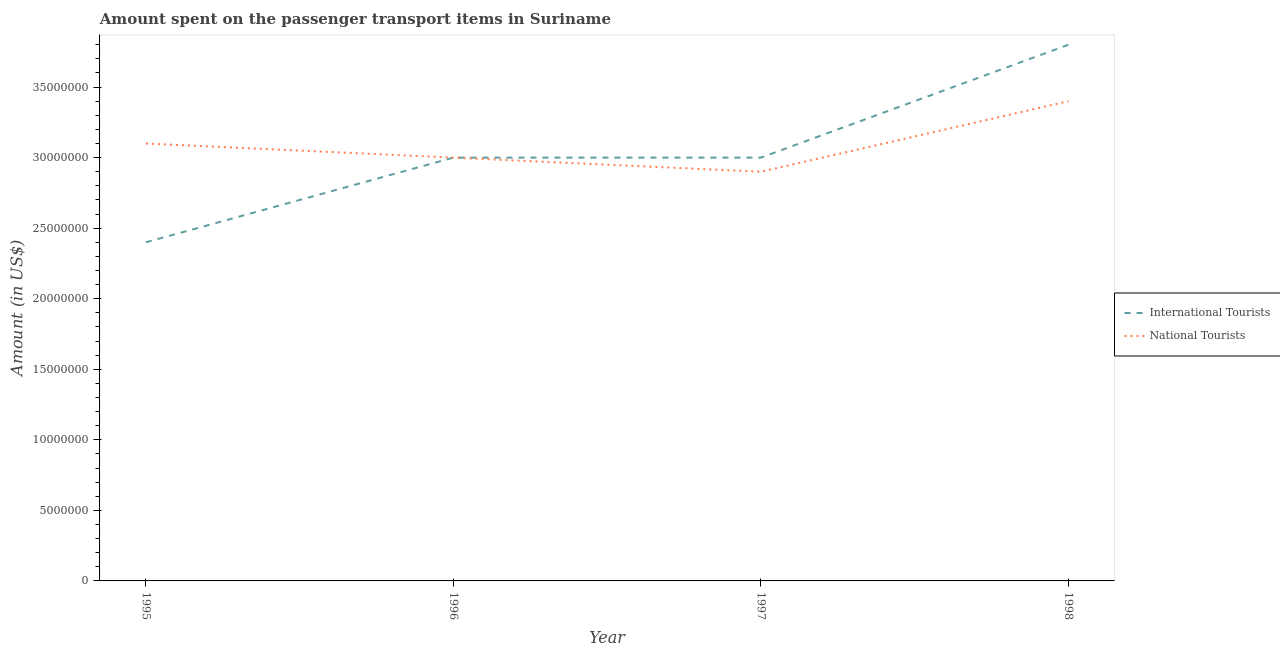Does the line corresponding to amount spent on transport items of international tourists intersect with the line corresponding to amount spent on transport items of national tourists?
Offer a very short reply. Yes. What is the amount spent on transport items of international tourists in 1997?
Provide a short and direct response. 3.00e+07. Across all years, what is the maximum amount spent on transport items of national tourists?
Give a very brief answer. 3.40e+07. Across all years, what is the minimum amount spent on transport items of national tourists?
Ensure brevity in your answer.  2.90e+07. In which year was the amount spent on transport items of national tourists maximum?
Offer a very short reply. 1998. What is the total amount spent on transport items of international tourists in the graph?
Keep it short and to the point. 1.22e+08. What is the difference between the amount spent on transport items of national tourists in 1995 and that in 1996?
Keep it short and to the point. 1.00e+06. What is the difference between the amount spent on transport items of national tourists in 1996 and the amount spent on transport items of international tourists in 1995?
Your answer should be very brief. 6.00e+06. What is the average amount spent on transport items of national tourists per year?
Offer a very short reply. 3.10e+07. In the year 1997, what is the difference between the amount spent on transport items of national tourists and amount spent on transport items of international tourists?
Offer a terse response. -1.00e+06. In how many years, is the amount spent on transport items of international tourists greater than 4000000 US$?
Keep it short and to the point. 4. What is the ratio of the amount spent on transport items of national tourists in 1997 to that in 1998?
Ensure brevity in your answer.  0.85. Is the amount spent on transport items of international tourists in 1997 less than that in 1998?
Offer a terse response. Yes. Is the difference between the amount spent on transport items of national tourists in 1995 and 1996 greater than the difference between the amount spent on transport items of international tourists in 1995 and 1996?
Provide a succinct answer. Yes. What is the difference between the highest and the lowest amount spent on transport items of national tourists?
Your answer should be very brief. 5.00e+06. In how many years, is the amount spent on transport items of national tourists greater than the average amount spent on transport items of national tourists taken over all years?
Give a very brief answer. 1. Is the amount spent on transport items of national tourists strictly greater than the amount spent on transport items of international tourists over the years?
Your response must be concise. No. Is the amount spent on transport items of national tourists strictly less than the amount spent on transport items of international tourists over the years?
Provide a short and direct response. No. How many lines are there?
Make the answer very short. 2. How many years are there in the graph?
Offer a terse response. 4. Are the values on the major ticks of Y-axis written in scientific E-notation?
Keep it short and to the point. No. Does the graph contain any zero values?
Ensure brevity in your answer.  No. How many legend labels are there?
Keep it short and to the point. 2. What is the title of the graph?
Your answer should be compact. Amount spent on the passenger transport items in Suriname. Does "Electricity and heat production" appear as one of the legend labels in the graph?
Ensure brevity in your answer.  No. What is the label or title of the X-axis?
Your answer should be very brief. Year. What is the label or title of the Y-axis?
Give a very brief answer. Amount (in US$). What is the Amount (in US$) in International Tourists in 1995?
Ensure brevity in your answer.  2.40e+07. What is the Amount (in US$) in National Tourists in 1995?
Make the answer very short. 3.10e+07. What is the Amount (in US$) in International Tourists in 1996?
Keep it short and to the point. 3.00e+07. What is the Amount (in US$) of National Tourists in 1996?
Provide a succinct answer. 3.00e+07. What is the Amount (in US$) in International Tourists in 1997?
Your answer should be compact. 3.00e+07. What is the Amount (in US$) of National Tourists in 1997?
Keep it short and to the point. 2.90e+07. What is the Amount (in US$) in International Tourists in 1998?
Ensure brevity in your answer.  3.80e+07. What is the Amount (in US$) in National Tourists in 1998?
Offer a very short reply. 3.40e+07. Across all years, what is the maximum Amount (in US$) in International Tourists?
Your answer should be very brief. 3.80e+07. Across all years, what is the maximum Amount (in US$) of National Tourists?
Your answer should be compact. 3.40e+07. Across all years, what is the minimum Amount (in US$) of International Tourists?
Make the answer very short. 2.40e+07. Across all years, what is the minimum Amount (in US$) of National Tourists?
Keep it short and to the point. 2.90e+07. What is the total Amount (in US$) in International Tourists in the graph?
Keep it short and to the point. 1.22e+08. What is the total Amount (in US$) of National Tourists in the graph?
Give a very brief answer. 1.24e+08. What is the difference between the Amount (in US$) of International Tourists in 1995 and that in 1996?
Your answer should be compact. -6.00e+06. What is the difference between the Amount (in US$) of National Tourists in 1995 and that in 1996?
Keep it short and to the point. 1.00e+06. What is the difference between the Amount (in US$) in International Tourists in 1995 and that in 1997?
Provide a short and direct response. -6.00e+06. What is the difference between the Amount (in US$) in International Tourists in 1995 and that in 1998?
Give a very brief answer. -1.40e+07. What is the difference between the Amount (in US$) in National Tourists in 1995 and that in 1998?
Your answer should be compact. -3.00e+06. What is the difference between the Amount (in US$) in International Tourists in 1996 and that in 1998?
Provide a succinct answer. -8.00e+06. What is the difference between the Amount (in US$) in International Tourists in 1997 and that in 1998?
Offer a very short reply. -8.00e+06. What is the difference between the Amount (in US$) in National Tourists in 1997 and that in 1998?
Ensure brevity in your answer.  -5.00e+06. What is the difference between the Amount (in US$) in International Tourists in 1995 and the Amount (in US$) in National Tourists in 1996?
Give a very brief answer. -6.00e+06. What is the difference between the Amount (in US$) of International Tourists in 1995 and the Amount (in US$) of National Tourists in 1997?
Make the answer very short. -5.00e+06. What is the difference between the Amount (in US$) of International Tourists in 1995 and the Amount (in US$) of National Tourists in 1998?
Give a very brief answer. -1.00e+07. What is the difference between the Amount (in US$) of International Tourists in 1996 and the Amount (in US$) of National Tourists in 1997?
Provide a succinct answer. 1.00e+06. What is the difference between the Amount (in US$) of International Tourists in 1997 and the Amount (in US$) of National Tourists in 1998?
Offer a very short reply. -4.00e+06. What is the average Amount (in US$) of International Tourists per year?
Your answer should be compact. 3.05e+07. What is the average Amount (in US$) in National Tourists per year?
Offer a terse response. 3.10e+07. In the year 1995, what is the difference between the Amount (in US$) in International Tourists and Amount (in US$) in National Tourists?
Provide a succinct answer. -7.00e+06. In the year 1996, what is the difference between the Amount (in US$) in International Tourists and Amount (in US$) in National Tourists?
Your response must be concise. 0. In the year 1997, what is the difference between the Amount (in US$) of International Tourists and Amount (in US$) of National Tourists?
Offer a very short reply. 1.00e+06. What is the ratio of the Amount (in US$) of International Tourists in 1995 to that in 1997?
Offer a very short reply. 0.8. What is the ratio of the Amount (in US$) of National Tourists in 1995 to that in 1997?
Make the answer very short. 1.07. What is the ratio of the Amount (in US$) in International Tourists in 1995 to that in 1998?
Offer a terse response. 0.63. What is the ratio of the Amount (in US$) of National Tourists in 1995 to that in 1998?
Keep it short and to the point. 0.91. What is the ratio of the Amount (in US$) of International Tourists in 1996 to that in 1997?
Offer a very short reply. 1. What is the ratio of the Amount (in US$) of National Tourists in 1996 to that in 1997?
Provide a succinct answer. 1.03. What is the ratio of the Amount (in US$) of International Tourists in 1996 to that in 1998?
Your answer should be compact. 0.79. What is the ratio of the Amount (in US$) of National Tourists in 1996 to that in 1998?
Ensure brevity in your answer.  0.88. What is the ratio of the Amount (in US$) in International Tourists in 1997 to that in 1998?
Make the answer very short. 0.79. What is the ratio of the Amount (in US$) of National Tourists in 1997 to that in 1998?
Your response must be concise. 0.85. What is the difference between the highest and the second highest Amount (in US$) of International Tourists?
Provide a succinct answer. 8.00e+06. What is the difference between the highest and the lowest Amount (in US$) in International Tourists?
Your answer should be very brief. 1.40e+07. What is the difference between the highest and the lowest Amount (in US$) in National Tourists?
Offer a very short reply. 5.00e+06. 